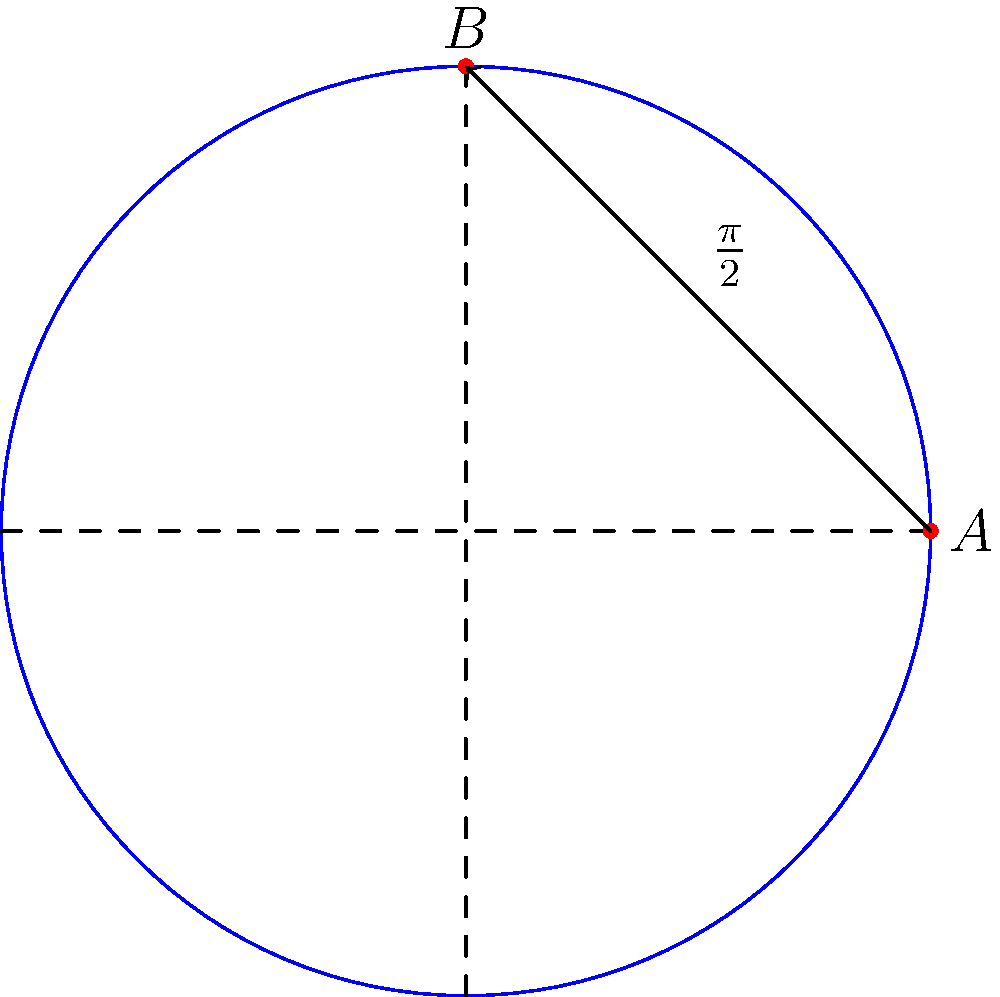In a circular harbor with a radius of 3 nautical miles, a naval vessel needs to patrol from point A (3, 0) to point B (0, 3) along the harbor's perimeter. What is the length of the patrol route in nautical miles? To solve this problem, we'll use the concept of arc length in polar coordinates:

1. Recognize that the harbor is represented by a circle with radius $r = 3$ nautical miles.

2. Identify that points A and B form a quarter of the circle's circumference (90° or $\frac{\pi}{2}$ radians).

3. Recall the formula for arc length: $s = r\theta$, where $s$ is the arc length, $r$ is the radius, and $\theta$ is the central angle in radians.

4. Substitute the values:
   $s = 3 \cdot \frac{\pi}{2}$

5. Calculate:
   $s = \frac{3\pi}{2}$ nautical miles

Therefore, the length of the patrol route is $\frac{3\pi}{2}$ nautical miles.
Answer: $\frac{3\pi}{2}$ nautical miles 